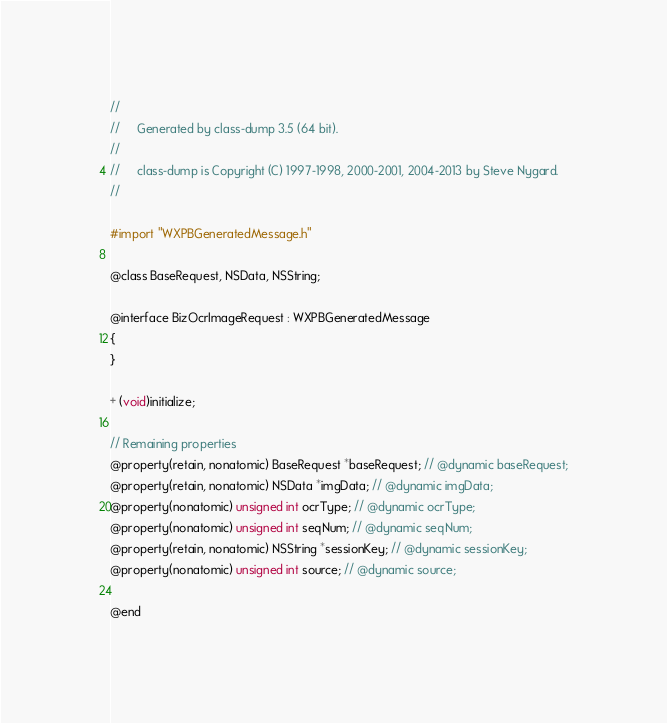<code> <loc_0><loc_0><loc_500><loc_500><_C_>//
//     Generated by class-dump 3.5 (64 bit).
//
//     class-dump is Copyright (C) 1997-1998, 2000-2001, 2004-2013 by Steve Nygard.
//

#import "WXPBGeneratedMessage.h"

@class BaseRequest, NSData, NSString;

@interface BizOcrImageRequest : WXPBGeneratedMessage
{
}

+ (void)initialize;

// Remaining properties
@property(retain, nonatomic) BaseRequest *baseRequest; // @dynamic baseRequest;
@property(retain, nonatomic) NSData *imgData; // @dynamic imgData;
@property(nonatomic) unsigned int ocrType; // @dynamic ocrType;
@property(nonatomic) unsigned int seqNum; // @dynamic seqNum;
@property(retain, nonatomic) NSString *sessionKey; // @dynamic sessionKey;
@property(nonatomic) unsigned int source; // @dynamic source;

@end

</code> 